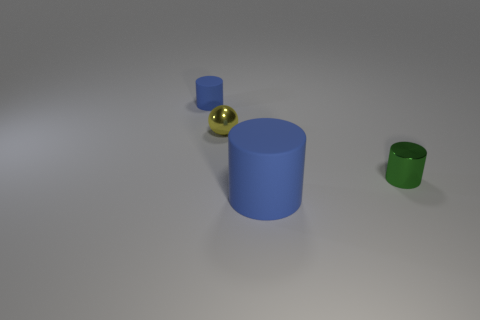Does the big object have the same material as the small blue thing?
Ensure brevity in your answer.  Yes. What color is the cylinder that is both on the left side of the metal cylinder and behind the big blue object?
Offer a very short reply. Blue. Is there a red thing of the same size as the ball?
Offer a very short reply. No. What size is the rubber object on the right side of the blue matte cylinder that is to the left of the yellow metallic thing?
Give a very brief answer. Large. Is the number of yellow shiny balls that are to the right of the tiny metallic sphere less than the number of large brown things?
Keep it short and to the point. No. Is the color of the large rubber cylinder the same as the small matte object?
Give a very brief answer. Yes. What number of tiny things have the same color as the large thing?
Provide a short and direct response. 1. Is there a cylinder that is on the right side of the metallic object right of the blue rubber cylinder that is in front of the tiny green shiny thing?
Provide a short and direct response. No. The other metallic object that is the same size as the yellow shiny thing is what shape?
Give a very brief answer. Cylinder. What number of large things are either gray matte balls or green things?
Your response must be concise. 0. 